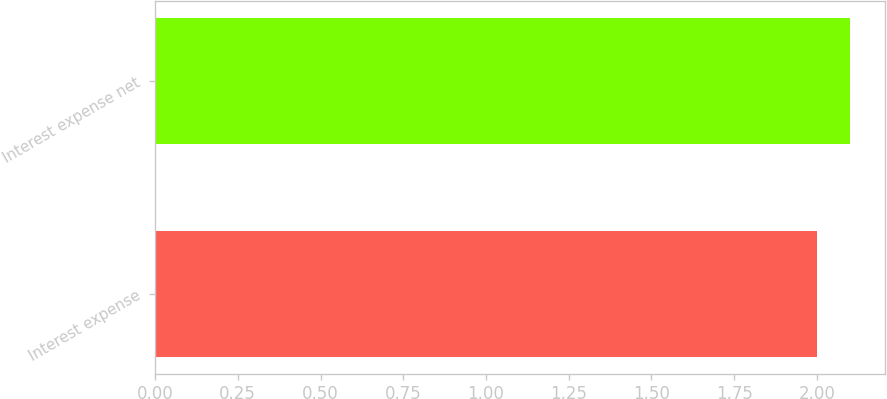<chart> <loc_0><loc_0><loc_500><loc_500><bar_chart><fcel>Interest expense<fcel>Interest expense net<nl><fcel>2<fcel>2.1<nl></chart> 